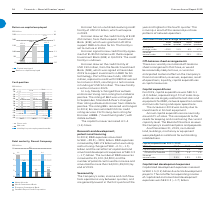According to Lm Ericsson Telephone's financial document, What is the capital expenditure of 2017? According to the financial document, 3.9 (in billions). The relevant text states: "Capital expenditures 5.1 4.0 3.9 Of which in Sweden 2.0 1.3 1.5 Share of annual sales 2.3% 1.9% 1.9%..." Also, What has been pledged as collateral for outstanding indebtedness in 2019? no material land, buildings, machinery or equipment were pledged. The document states: "ent plans and proposals. As of December 31, 2019, no material land, buildings, machinery or equipment were pledged as collateral for outstanding indeb..." Also, Why was there an increase in capital expenditure in 2019? investments in 5G test equipment. The document states: "perations. The increase in 2019 was mainly due to investments in 5G test equipment. Annual capital expenditures are normally around 2% of sales. This ..." Also, can you calculate: What is the change between capital expenditure in 2019 and 2018? Based on the calculation: 5.1-4.0, the result is 1.1 (in billions). This is based on the information: "Capital expenditures 5.1 4.0 3.9 Of which in Sweden 2.0 1.3 1.5 Share of annual sales 2.3% 1.9% 1.9% Capital expenditures 5.1 4.0 3.9 Of which in Sweden 2.0 1.3 1.5 Share of annual sales 2.3% 1.9% 1.9..." The key data points involved are: 4.0, 5.1. Also, can you calculate: What is the change in share of annual sales between 2018 and 2019? Based on the calculation: 2.3-1.9, the result is 0.4 (percentage). This is based on the information: "in Sweden 2.0 1.3 1.5 Share of annual sales 2.3% 1.9% 1.9% which in Sweden 2.0 1.3 1.5 Share of annual sales 2.3% 1.9% 1.9%..." The key data points involved are: 1.9, 2.3. Additionally, Which year has a higher capital expenditures? According to the financial document, 2019. The relevant text states: "Capital expenditures 2017–2019..." 